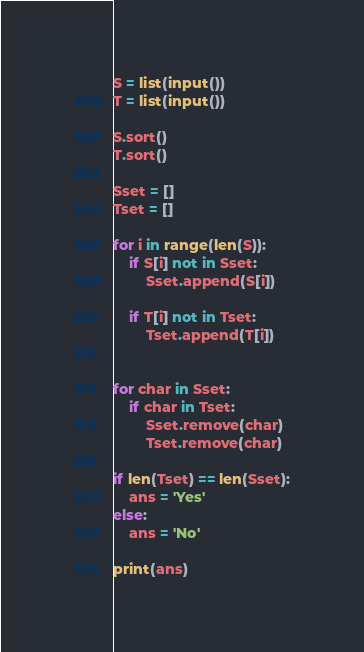<code> <loc_0><loc_0><loc_500><loc_500><_Python_>S = list(input())
T = list(input())

S.sort()
T.sort()

Sset = []
Tset = []

for i in range(len(S)):
    if S[i] not in Sset:    
        Sset.append(S[i])

    if T[i] not in Tset:
        Tset.append(T[i])


for char in Sset:
    if char in Tset:
        Sset.remove(char)
        Tset.remove(char)

if len(Tset) == len(Sset):
    ans = 'Yes' 
else:
    ans = 'No'

print(ans)</code> 